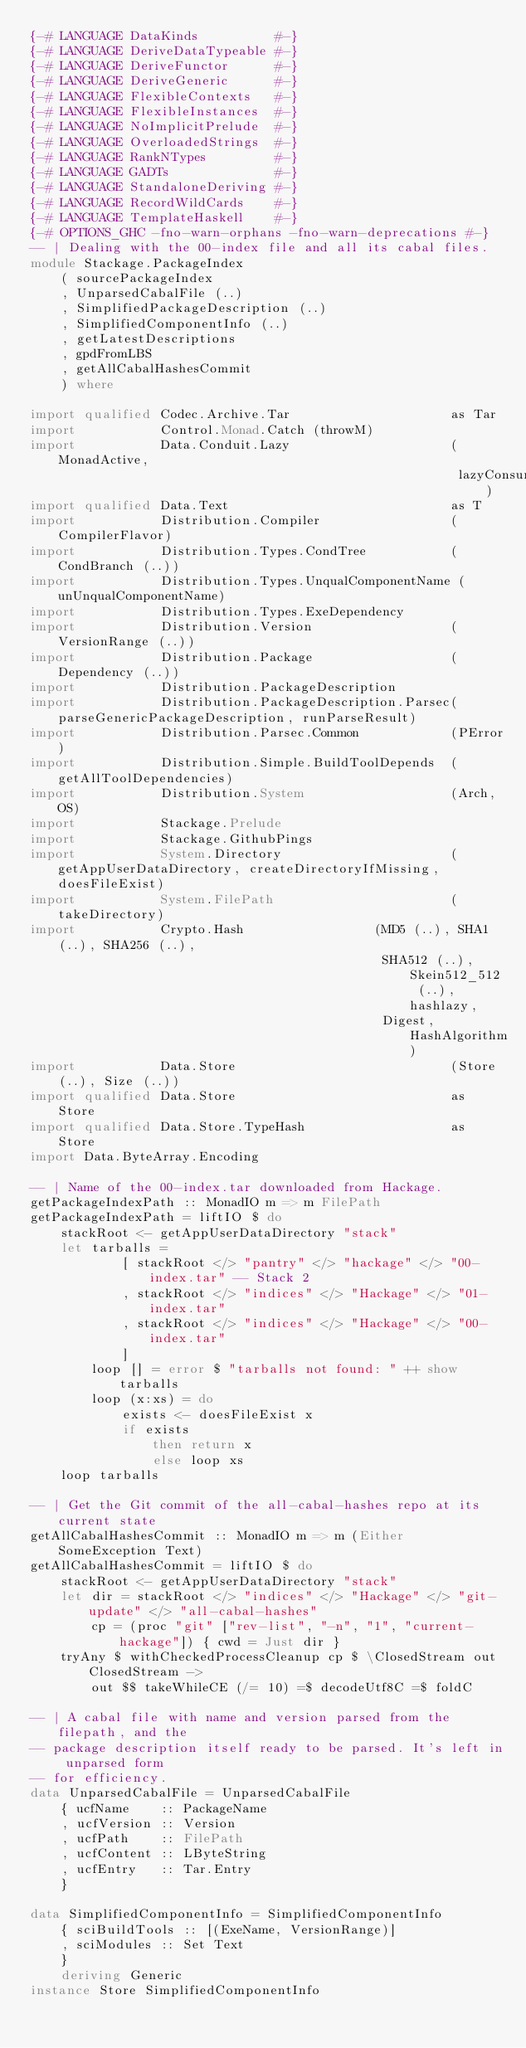<code> <loc_0><loc_0><loc_500><loc_500><_Haskell_>{-# LANGUAGE DataKinds          #-}
{-# LANGUAGE DeriveDataTypeable #-}
{-# LANGUAGE DeriveFunctor      #-}
{-# LANGUAGE DeriveGeneric      #-}
{-# LANGUAGE FlexibleContexts   #-}
{-# LANGUAGE FlexibleInstances  #-}
{-# LANGUAGE NoImplicitPrelude  #-}
{-# LANGUAGE OverloadedStrings  #-}
{-# LANGUAGE RankNTypes         #-}
{-# LANGUAGE GADTs              #-}
{-# LANGUAGE StandaloneDeriving #-}
{-# LANGUAGE RecordWildCards    #-}
{-# LANGUAGE TemplateHaskell    #-}
{-# OPTIONS_GHC -fno-warn-orphans -fno-warn-deprecations #-}
-- | Dealing with the 00-index file and all its cabal files.
module Stackage.PackageIndex
    ( sourcePackageIndex
    , UnparsedCabalFile (..)
    , SimplifiedPackageDescription (..)
    , SimplifiedComponentInfo (..)
    , getLatestDescriptions
    , gpdFromLBS
    , getAllCabalHashesCommit
    ) where

import qualified Codec.Archive.Tar                     as Tar
import           Control.Monad.Catch (throwM)
import           Data.Conduit.Lazy                     (MonadActive,
                                                        lazyConsume)
import qualified Data.Text                             as T
import           Distribution.Compiler                 (CompilerFlavor)
import           Distribution.Types.CondTree           (CondBranch (..))
import           Distribution.Types.UnqualComponentName (unUnqualComponentName)
import           Distribution.Types.ExeDependency
import           Distribution.Version                  (VersionRange (..))
import           Distribution.Package                  (Dependency (..))
import           Distribution.PackageDescription
import           Distribution.PackageDescription.Parsec(parseGenericPackageDescription, runParseResult)
import           Distribution.Parsec.Common            (PError)
import           Distribution.Simple.BuildToolDepends  (getAllToolDependencies)
import           Distribution.System                   (Arch, OS)
import           Stackage.Prelude
import           Stackage.GithubPings
import           System.Directory                      (getAppUserDataDirectory, createDirectoryIfMissing, doesFileExist)
import           System.FilePath                       (takeDirectory)
import           Crypto.Hash                 (MD5 (..), SHA1 (..), SHA256 (..),
                                              SHA512 (..), Skein512_512 (..), hashlazy,
                                              Digest, HashAlgorithm)
import           Data.Store                            (Store (..), Size (..))
import qualified Data.Store                            as Store
import qualified Data.Store.TypeHash                   as Store
import Data.ByteArray.Encoding

-- | Name of the 00-index.tar downloaded from Hackage.
getPackageIndexPath :: MonadIO m => m FilePath
getPackageIndexPath = liftIO $ do
    stackRoot <- getAppUserDataDirectory "stack"
    let tarballs =
            [ stackRoot </> "pantry" </> "hackage" </> "00-index.tar" -- Stack 2
            , stackRoot </> "indices" </> "Hackage" </> "01-index.tar"
            , stackRoot </> "indices" </> "Hackage" </> "00-index.tar"
            ]
        loop [] = error $ "tarballs not found: " ++ show tarballs
        loop (x:xs) = do
            exists <- doesFileExist x
            if exists
                then return x
                else loop xs
    loop tarballs

-- | Get the Git commit of the all-cabal-hashes repo at its current state
getAllCabalHashesCommit :: MonadIO m => m (Either SomeException Text)
getAllCabalHashesCommit = liftIO $ do
    stackRoot <- getAppUserDataDirectory "stack"
    let dir = stackRoot </> "indices" </> "Hackage" </> "git-update" </> "all-cabal-hashes"
        cp = (proc "git" ["rev-list", "-n", "1", "current-hackage"]) { cwd = Just dir }
    tryAny $ withCheckedProcessCleanup cp $ \ClosedStream out ClosedStream ->
        out $$ takeWhileCE (/= 10) =$ decodeUtf8C =$ foldC

-- | A cabal file with name and version parsed from the filepath, and the
-- package description itself ready to be parsed. It's left in unparsed form
-- for efficiency.
data UnparsedCabalFile = UnparsedCabalFile
    { ucfName    :: PackageName
    , ucfVersion :: Version
    , ucfPath    :: FilePath
    , ucfContent :: LByteString
    , ucfEntry   :: Tar.Entry
    }

data SimplifiedComponentInfo = SimplifiedComponentInfo
    { sciBuildTools :: [(ExeName, VersionRange)]
    , sciModules :: Set Text
    }
    deriving Generic
instance Store SimplifiedComponentInfo
</code> 